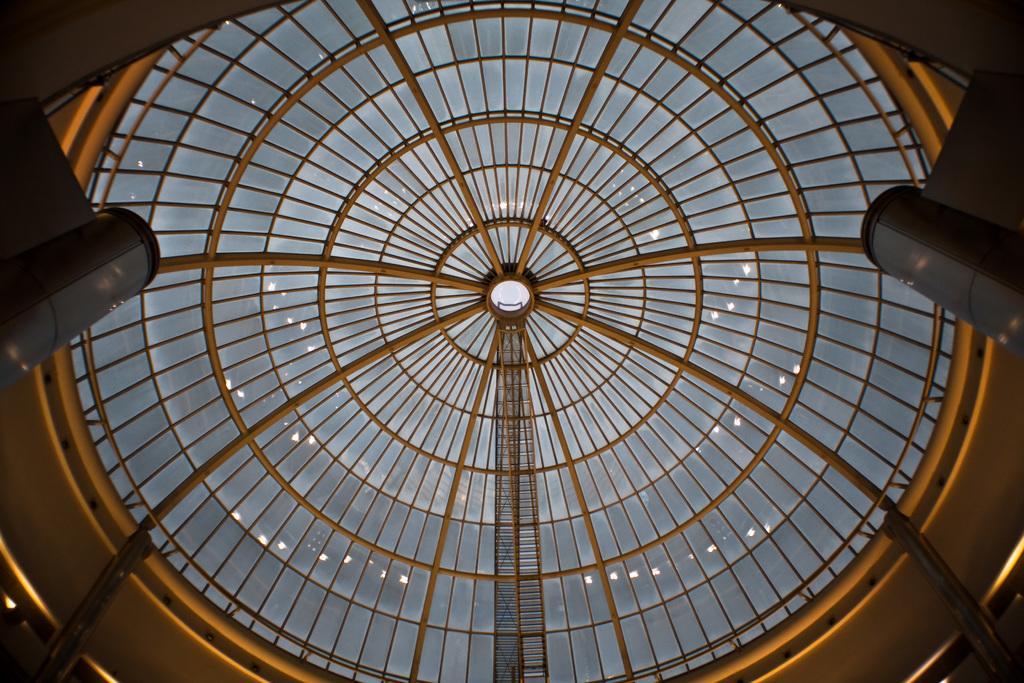Could you give a brief overview of what you see in this image? On the left and right side we can see objects. In the background we can see glass roof, poles and wall. 